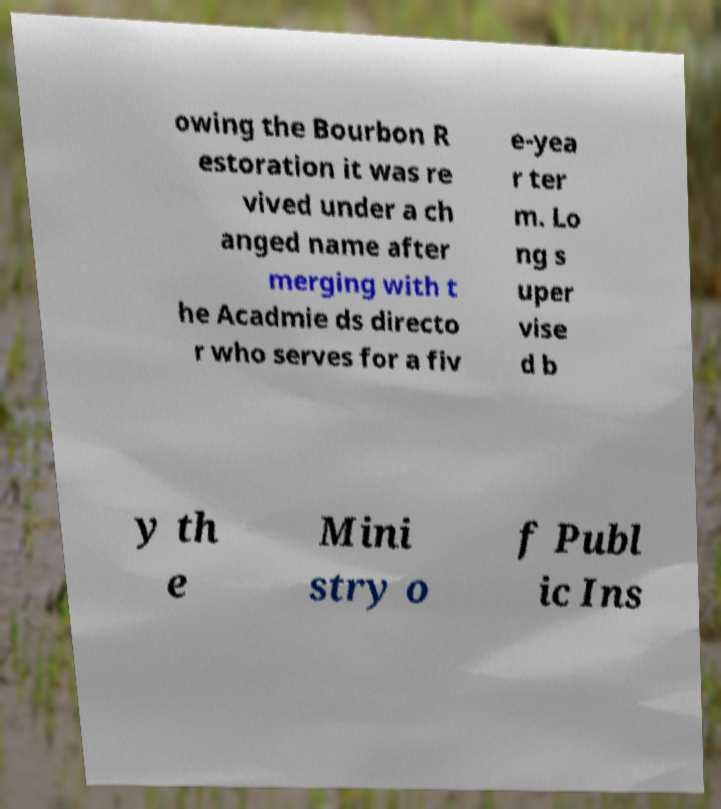There's text embedded in this image that I need extracted. Can you transcribe it verbatim? owing the Bourbon R estoration it was re vived under a ch anged name after merging with t he Acadmie ds directo r who serves for a fiv e-yea r ter m. Lo ng s uper vise d b y th e Mini stry o f Publ ic Ins 